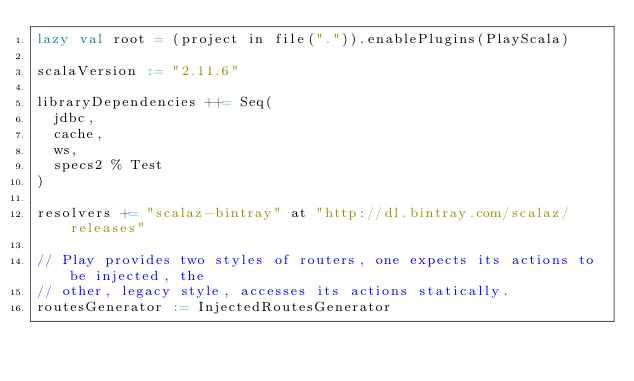<code> <loc_0><loc_0><loc_500><loc_500><_Scala_>lazy val root = (project in file(".")).enablePlugins(PlayScala)

scalaVersion := "2.11.6"

libraryDependencies ++= Seq(
  jdbc,
  cache,
  ws,
  specs2 % Test
)

resolvers += "scalaz-bintray" at "http://dl.bintray.com/scalaz/releases"

// Play provides two styles of routers, one expects its actions to be injected, the
// other, legacy style, accesses its actions statically.
routesGenerator := InjectedRoutesGenerator
</code> 